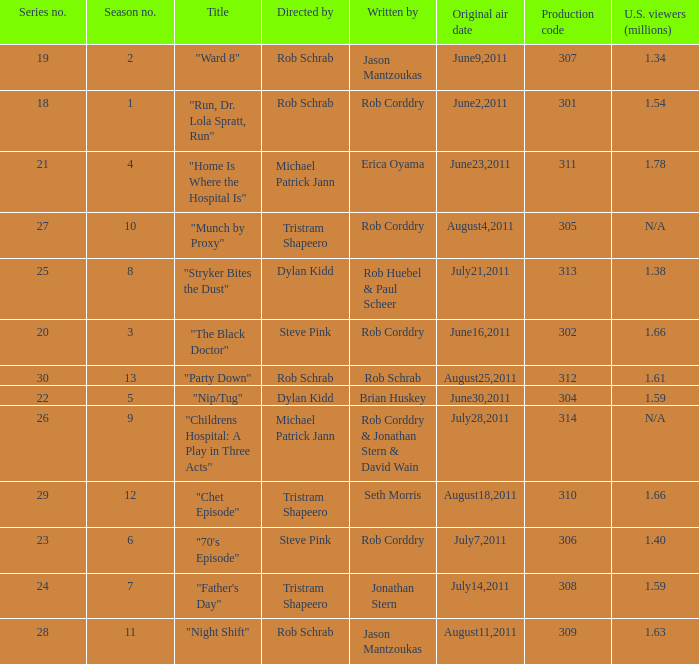At most what number in the series was the episode "chet episode"? 29.0. 